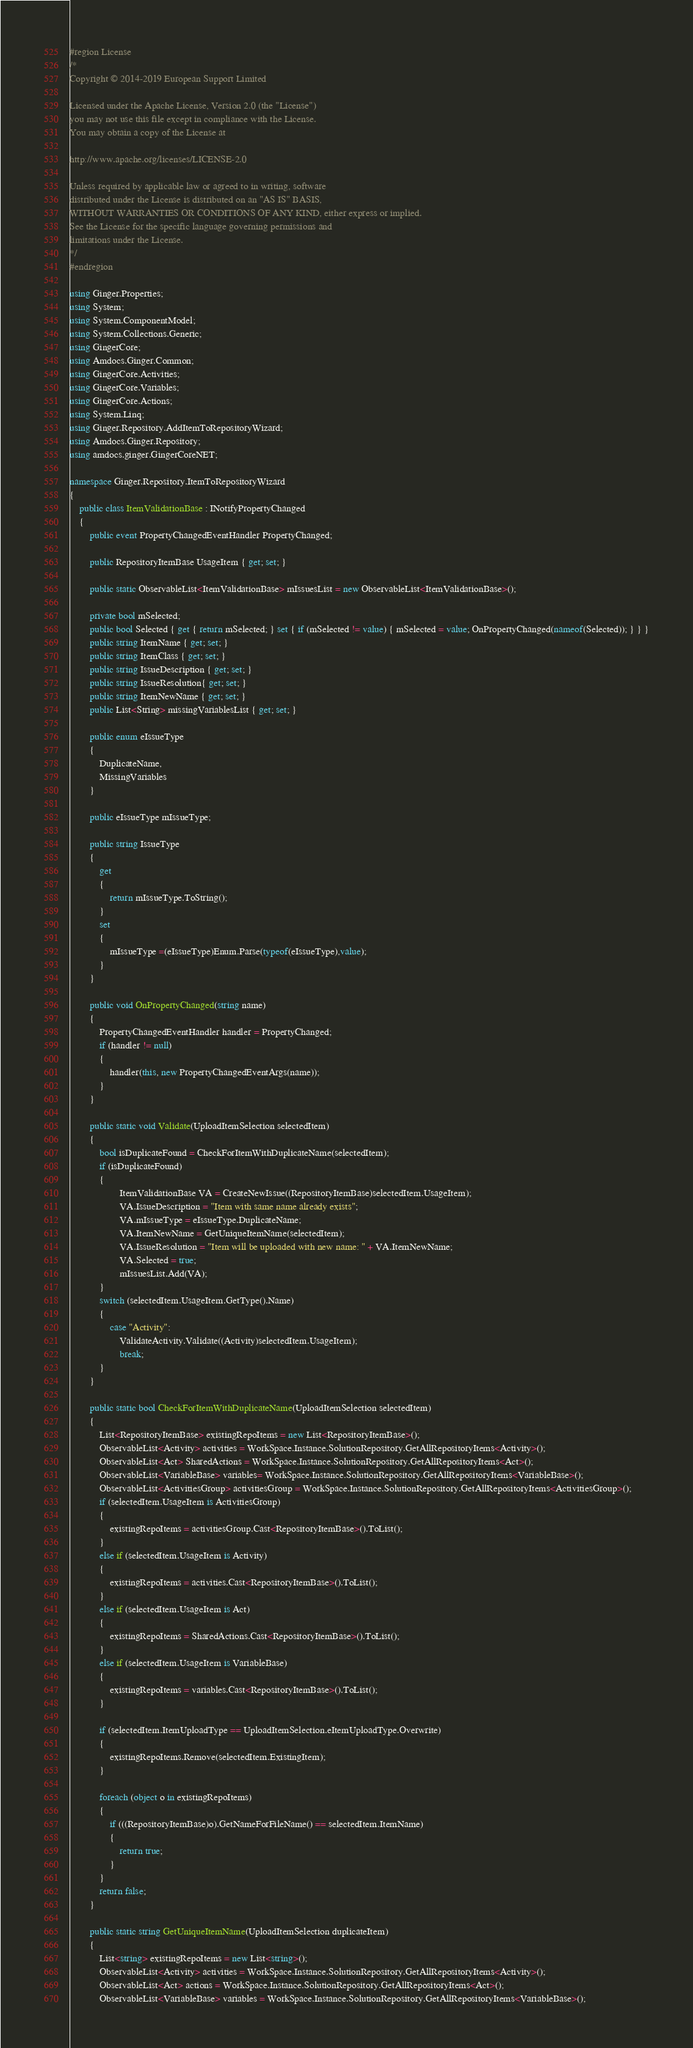Convert code to text. <code><loc_0><loc_0><loc_500><loc_500><_C#_>#region License
/*
Copyright © 2014-2019 European Support Limited

Licensed under the Apache License, Version 2.0 (the "License")
you may not use this file except in compliance with the License.
You may obtain a copy of the License at 

http://www.apache.org/licenses/LICENSE-2.0 

Unless required by applicable law or agreed to in writing, software
distributed under the License is distributed on an "AS IS" BASIS, 
WITHOUT WARRANTIES OR CONDITIONS OF ANY KIND, either express or implied. 
See the License for the specific language governing permissions and 
limitations under the License. 
*/
#endregion

using Ginger.Properties;
using System;
using System.ComponentModel;
using System.Collections.Generic;
using GingerCore;
using Amdocs.Ginger.Common;
using GingerCore.Activities;
using GingerCore.Variables;
using GingerCore.Actions;
using System.Linq;
using Ginger.Repository.AddItemToRepositoryWizard;
using Amdocs.Ginger.Repository;
using amdocs.ginger.GingerCoreNET;

namespace Ginger.Repository.ItemToRepositoryWizard
{
    public class ItemValidationBase : INotifyPropertyChanged
    {
        public event PropertyChangedEventHandler PropertyChanged;
       
        public RepositoryItemBase UsageItem { get; set; }

        public static ObservableList<ItemValidationBase> mIssuesList = new ObservableList<ItemValidationBase>();

        private bool mSelected;
        public bool Selected { get { return mSelected; } set { if (mSelected != value) { mSelected = value; OnPropertyChanged(nameof(Selected)); } } }
        public string ItemName { get; set; }
        public string ItemClass { get; set; }
        public string IssueDescription { get; set; }
        public string IssueResolution{ get; set; }
        public string ItemNewName { get; set; }
        public List<String> missingVariablesList { get; set; }

        public enum eIssueType
        {            
            DuplicateName,
            MissingVariables           
        }

        public eIssueType mIssueType;

        public string IssueType
        {
            get
            {
                return mIssueType.ToString();
            }           
            set
            {
                mIssueType =(eIssueType)Enum.Parse(typeof(eIssueType),value);
            }
        }

        public void OnPropertyChanged(string name)
        {
            PropertyChangedEventHandler handler = PropertyChanged;
            if (handler != null)
            {
                handler(this, new PropertyChangedEventArgs(name));
            }
        }

        public static void Validate(UploadItemSelection selectedItem)
        {  
            bool isDuplicateFound = CheckForItemWithDuplicateName(selectedItem);
            if (isDuplicateFound)
            {
                    ItemValidationBase VA = CreateNewIssue((RepositoryItemBase)selectedItem.UsageItem);
                    VA.IssueDescription = "Item with same name already exists";
                    VA.mIssueType = eIssueType.DuplicateName;
                    VA.ItemNewName = GetUniqueItemName(selectedItem);
                    VA.IssueResolution = "Item will be uploaded with new name: " + VA.ItemNewName;
                    VA.Selected = true;
                    mIssuesList.Add(VA);
            }
            switch (selectedItem.UsageItem.GetType().Name)
            {
                case "Activity":
                    ValidateActivity.Validate((Activity)selectedItem.UsageItem);
                    break;
            }
        }

        public static bool CheckForItemWithDuplicateName(UploadItemSelection selectedItem)
        {
            List<RepositoryItemBase> existingRepoItems = new List<RepositoryItemBase>();
            ObservableList<Activity> activities = WorkSpace.Instance.SolutionRepository.GetAllRepositoryItems<Activity>();
            ObservableList<Act> SharedActions = WorkSpace.Instance.SolutionRepository.GetAllRepositoryItems<Act>();
            ObservableList<VariableBase> variables= WorkSpace.Instance.SolutionRepository.GetAllRepositoryItems<VariableBase>();
            ObservableList<ActivitiesGroup> activitiesGroup = WorkSpace.Instance.SolutionRepository.GetAllRepositoryItems<ActivitiesGroup>();
            if (selectedItem.UsageItem is ActivitiesGroup)
            {
                existingRepoItems = activitiesGroup.Cast<RepositoryItemBase>().ToList();
            }
            else if (selectedItem.UsageItem is Activity)
            {
                existingRepoItems = activities.Cast<RepositoryItemBase>().ToList();
            }
            else if (selectedItem.UsageItem is Act)
            {
                existingRepoItems = SharedActions.Cast<RepositoryItemBase>().ToList();
            }
            else if (selectedItem.UsageItem is VariableBase)
            {
                existingRepoItems = variables.Cast<RepositoryItemBase>().ToList();
            }
            
            if (selectedItem.ItemUploadType == UploadItemSelection.eItemUploadType.Overwrite)
            {
                existingRepoItems.Remove(selectedItem.ExistingItem);
            }

            foreach (object o in existingRepoItems)
            {       
                if (((RepositoryItemBase)o).GetNameForFileName() == selectedItem.ItemName)
                {
                    return true;
                }
            }
            return false;
        }

        public static string GetUniqueItemName(UploadItemSelection duplicateItem)
        {
            List<string> existingRepoItems = new List<string>();
            ObservableList<Activity> activities = WorkSpace.Instance.SolutionRepository.GetAllRepositoryItems<Activity>();
            ObservableList<Act> actions = WorkSpace.Instance.SolutionRepository.GetAllRepositoryItems<Act>();
            ObservableList<VariableBase> variables = WorkSpace.Instance.SolutionRepository.GetAllRepositoryItems<VariableBase>();
</code> 